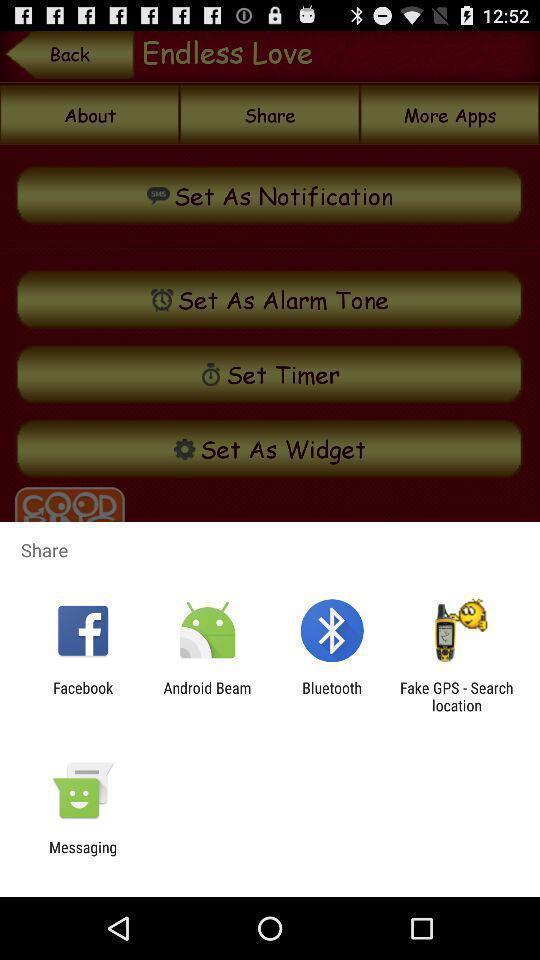What is the overall content of this screenshot? Widget displaying many data sharing apps. 